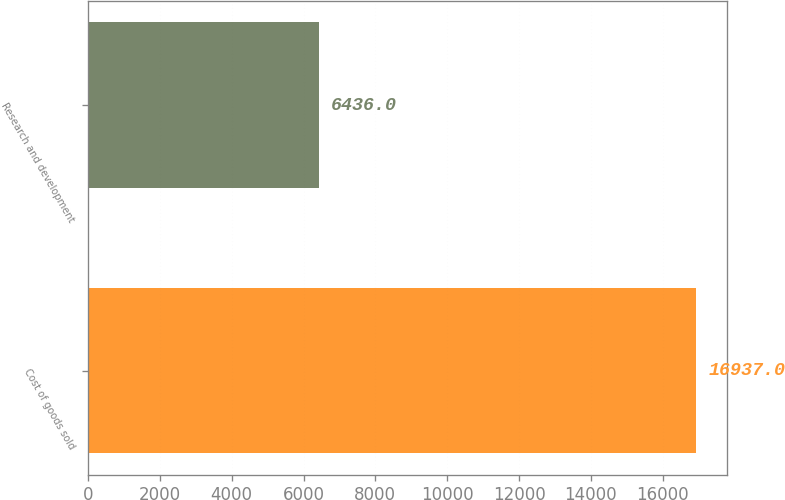Convert chart to OTSL. <chart><loc_0><loc_0><loc_500><loc_500><bar_chart><fcel>Cost of goods sold<fcel>Research and development<nl><fcel>16937<fcel>6436<nl></chart> 